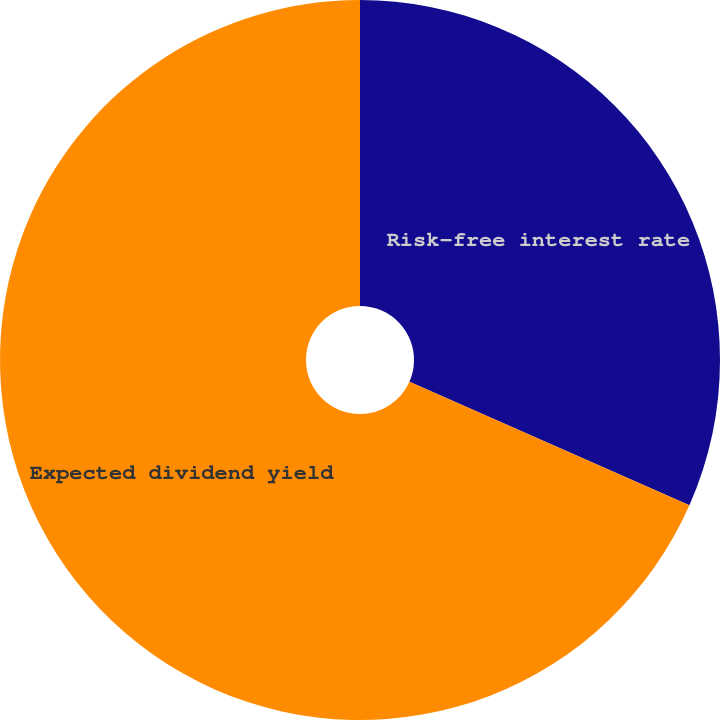Convert chart. <chart><loc_0><loc_0><loc_500><loc_500><pie_chart><fcel>Risk-free interest rate<fcel>Expected dividend yield<nl><fcel>31.61%<fcel>68.39%<nl></chart> 